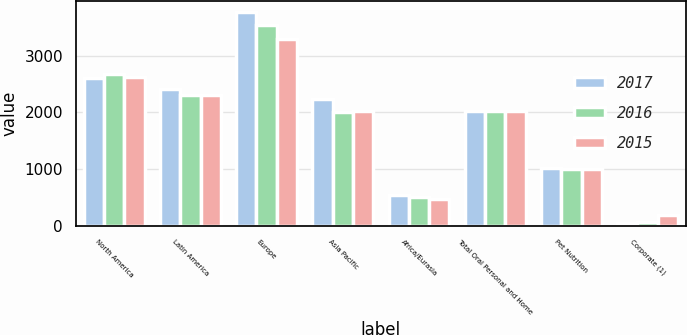Convert chart to OTSL. <chart><loc_0><loc_0><loc_500><loc_500><stacked_bar_chart><ecel><fcel>North America<fcel>Latin America<fcel>Europe<fcel>Asia Pacific<fcel>Africa/Eurasia<fcel>Total Oral Personal and Home<fcel>Pet Nutrition<fcel>Corporate (1)<nl><fcel>2017<fcel>2608<fcel>2423<fcel>3781<fcel>2244<fcel>544<fcel>2031<fcel>1026<fcel>50<nl><fcel>2016<fcel>2685<fcel>2314<fcel>3554<fcel>2006<fcel>499<fcel>2031<fcel>1009<fcel>56<nl><fcel>2015<fcel>2622<fcel>2314<fcel>3308<fcel>2031<fcel>476<fcel>2031<fcel>1006<fcel>178<nl></chart> 